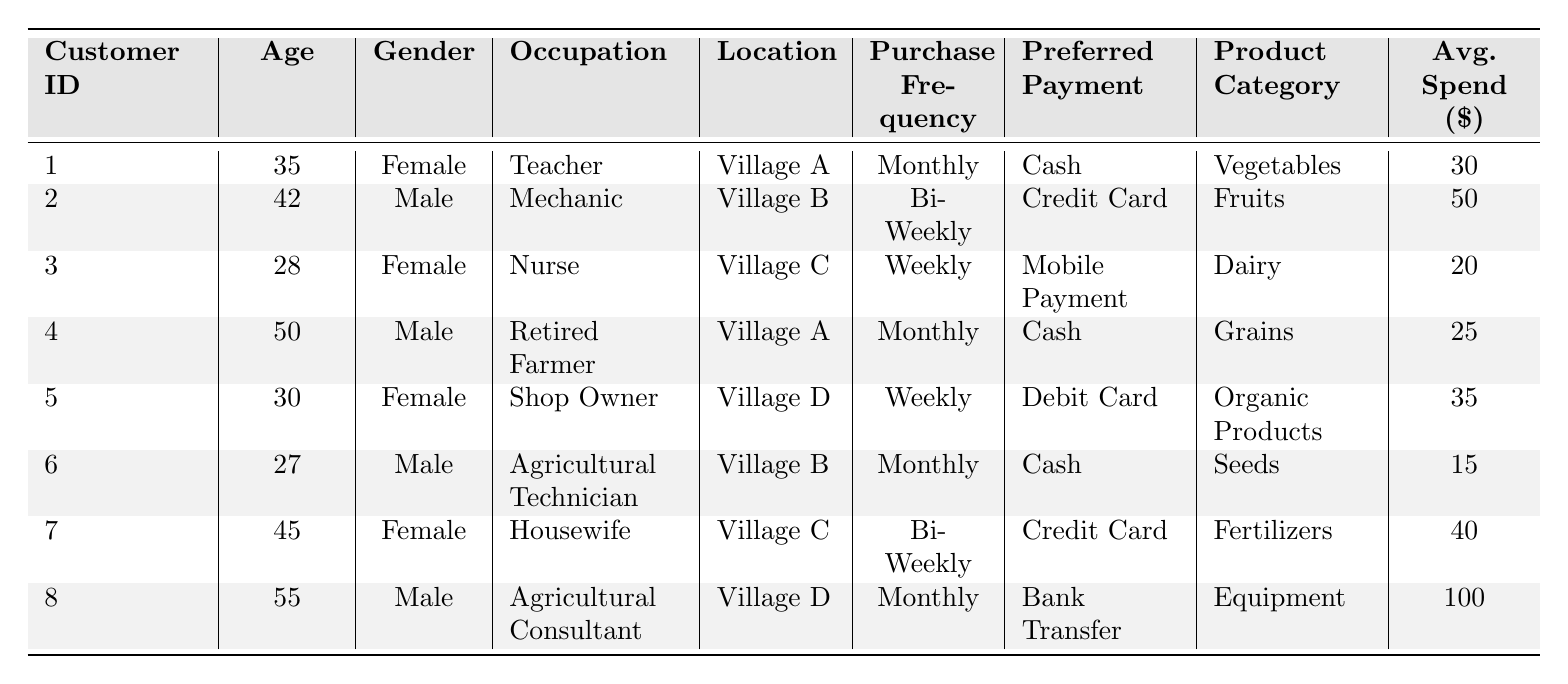What is the preferred payment method of Customer ID 3? Customer ID 3 displays the payment method "Mobile Payment" in the table. Therefore, the answer is based directly on the recorded information for that customer.
Answer: Mobile Payment How many customers prefer cash as their payment method? By examining the table, three customers (Customer IDs 1, 4, and 6) have listed "Cash" as their preferred payment method.
Answer: 3 What product category does Customer ID 8 purchase, and what is the average spend? Customer ID 8 is associated with the product category "Equipment" and an average spend of $100. This can be easily retrieved from the table data.
Answer: Equipment, 100 What is the average age of customers who purchase vegetables and grains? The average age of customers who purchase "Vegetables" (Customer ID 1, age 35) and "Grains" (Customer ID 4, age 50) can be calculated. The average is (35 + 50) / 2 = 42.5.
Answer: 42.5 Which customer has the highest average spend, and what do they purchase? Customer ID 8 has the highest average spend of $100 for the product category "Equipment." This is determined by comparing the average spends for all customers listed.
Answer: Customer ID 8, Equipment Is there any customer that has a bi-weekly purchase frequency and prefers credit card payment? Yes, Customer ID 2 is noted to have a bi-weekly purchase frequency and prefers credit card payment. This is directly confirmed by the table.
Answer: Yes What is the total average spend of customers from Village A? Customers from Village A (Customer ID 1 and 4) have average spends of $30 and $25, respectively. Therefore, the total average is 30 + 25 = 55.
Answer: 55 Are there more female or male customers, and how many of each? The table lists 4 female customers (IDs 1, 3, 5, 7) and 4 male customers (IDs 2, 4, 6, 8). Both genders have equal representation based on the table.
Answer: Equal, 4 each 